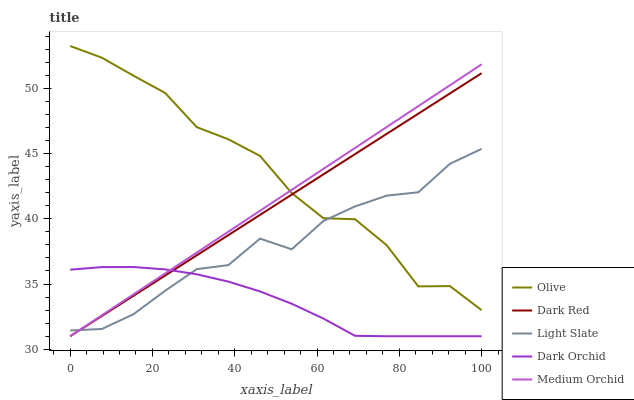Does Dark Orchid have the minimum area under the curve?
Answer yes or no. Yes. Does Olive have the maximum area under the curve?
Answer yes or no. Yes. Does Dark Red have the minimum area under the curve?
Answer yes or no. No. Does Dark Red have the maximum area under the curve?
Answer yes or no. No. Is Dark Red the smoothest?
Answer yes or no. Yes. Is Olive the roughest?
Answer yes or no. Yes. Is Medium Orchid the smoothest?
Answer yes or no. No. Is Medium Orchid the roughest?
Answer yes or no. No. Does Dark Red have the lowest value?
Answer yes or no. Yes. Does Light Slate have the lowest value?
Answer yes or no. No. Does Olive have the highest value?
Answer yes or no. Yes. Does Dark Red have the highest value?
Answer yes or no. No. Is Dark Orchid less than Olive?
Answer yes or no. Yes. Is Olive greater than Dark Orchid?
Answer yes or no. Yes. Does Medium Orchid intersect Light Slate?
Answer yes or no. Yes. Is Medium Orchid less than Light Slate?
Answer yes or no. No. Is Medium Orchid greater than Light Slate?
Answer yes or no. No. Does Dark Orchid intersect Olive?
Answer yes or no. No. 